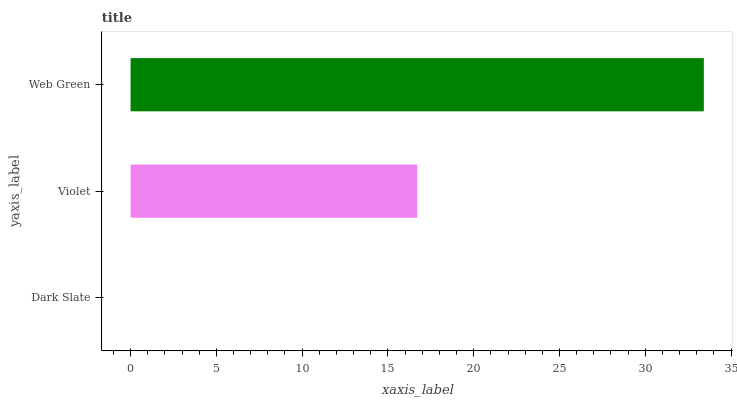Is Dark Slate the minimum?
Answer yes or no. Yes. Is Web Green the maximum?
Answer yes or no. Yes. Is Violet the minimum?
Answer yes or no. No. Is Violet the maximum?
Answer yes or no. No. Is Violet greater than Dark Slate?
Answer yes or no. Yes. Is Dark Slate less than Violet?
Answer yes or no. Yes. Is Dark Slate greater than Violet?
Answer yes or no. No. Is Violet less than Dark Slate?
Answer yes or no. No. Is Violet the high median?
Answer yes or no. Yes. Is Violet the low median?
Answer yes or no. Yes. Is Dark Slate the high median?
Answer yes or no. No. Is Dark Slate the low median?
Answer yes or no. No. 